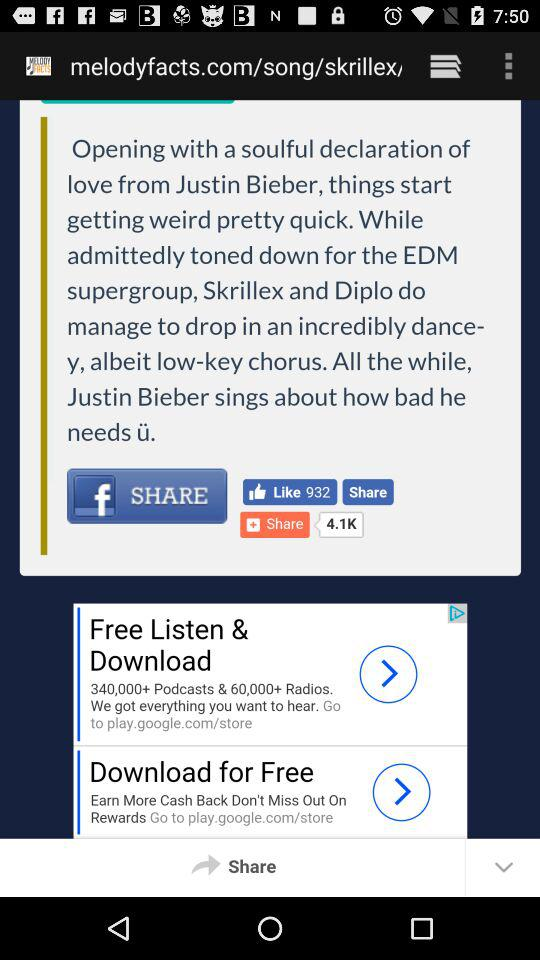Where can we share this post? You can share this post on "Facebook". 